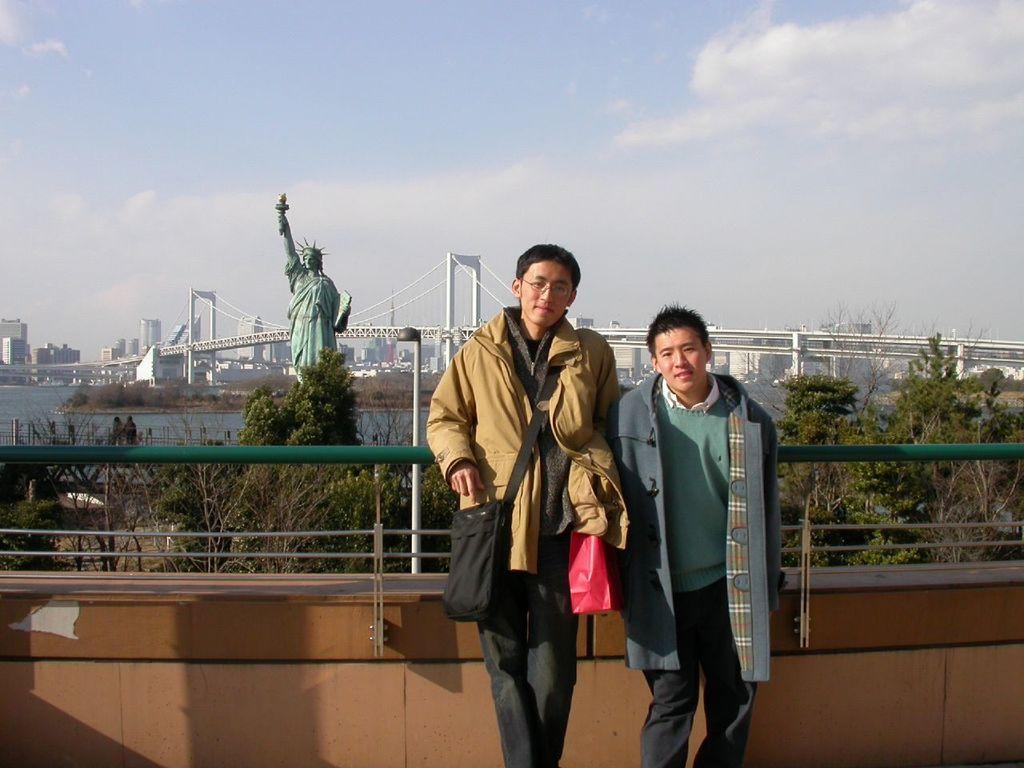In one or two sentences, can you explain what this image depicts? This image consists of two persons. On the left, the man is wearing a bag. In the background, there is a railing and a statue. And we can see a bridge. At the top, there is sky. And we can see trees and plants. 